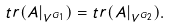<formula> <loc_0><loc_0><loc_500><loc_500>t r ( A | _ { V ^ { G _ { 1 } } } ) = t r ( A | _ { V ^ { G _ { 2 } } } ) .</formula> 